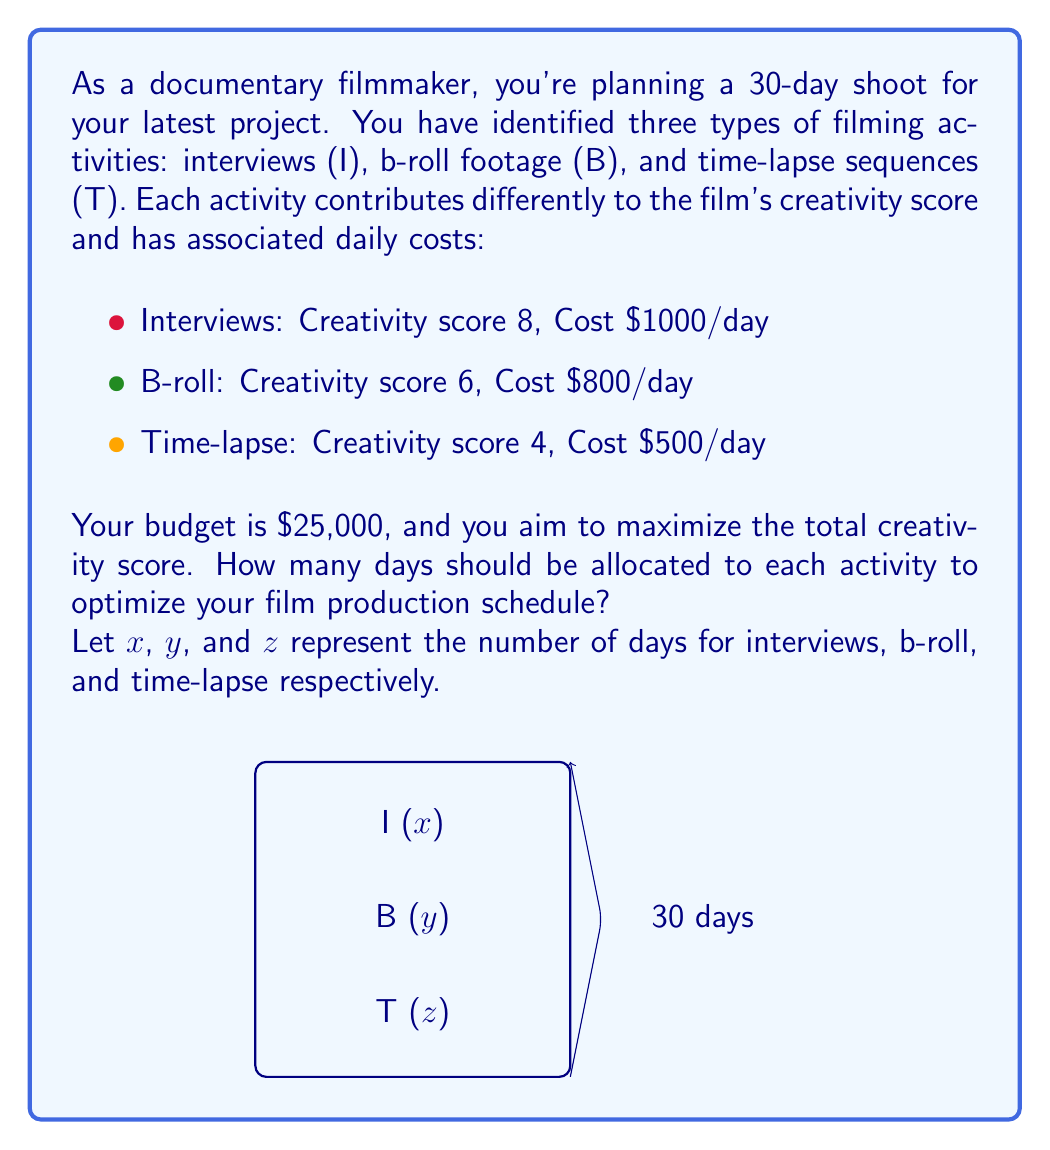Help me with this question. Let's approach this problem using linear programming:

1) Objective function: Maximize total creativity score
   $$ \text{Max } 8x + 6y + 4z $$

2) Constraints:
   a) Total days: $x + y + z = 30$
   b) Budget: $1000x + 800y + 500z \leq 25000$
   c) Non-negativity: $x, y, z \geq 0$

3) Simplify the budget constraint:
   $$ 2x + \frac{8}{5}y + z \leq 50 $$

4) We can solve this using the simplex method or graphical method. Let's use the graphical method for visualization.

5) Plot the constraints:
   - $x + y + z = 30$ (plane)
   - $2x + \frac{8}{5}y + z = 50$ (plane)

6) The feasible region is the intersection of these planes within the first octant.

7) The optimal solution will be at one of the vertices of this feasible region.

8) Checking the vertices:
   a) (25, 0, 5): Creativity score = 220
   b) (22.5, 7.5, 0): Creativity score = 225
   c) (20, 10, 0): Creativity score = 220

9) The optimal solution is (22.5, 7.5, 0), but we need integer values.

10) Rounding to the nearest integer while maintaining constraints:
    (23, 7, 0) gives a creativity score of 226 and meets all constraints.
Answer: 23 days for interviews, 7 days for b-roll, 0 days for time-lapse. 